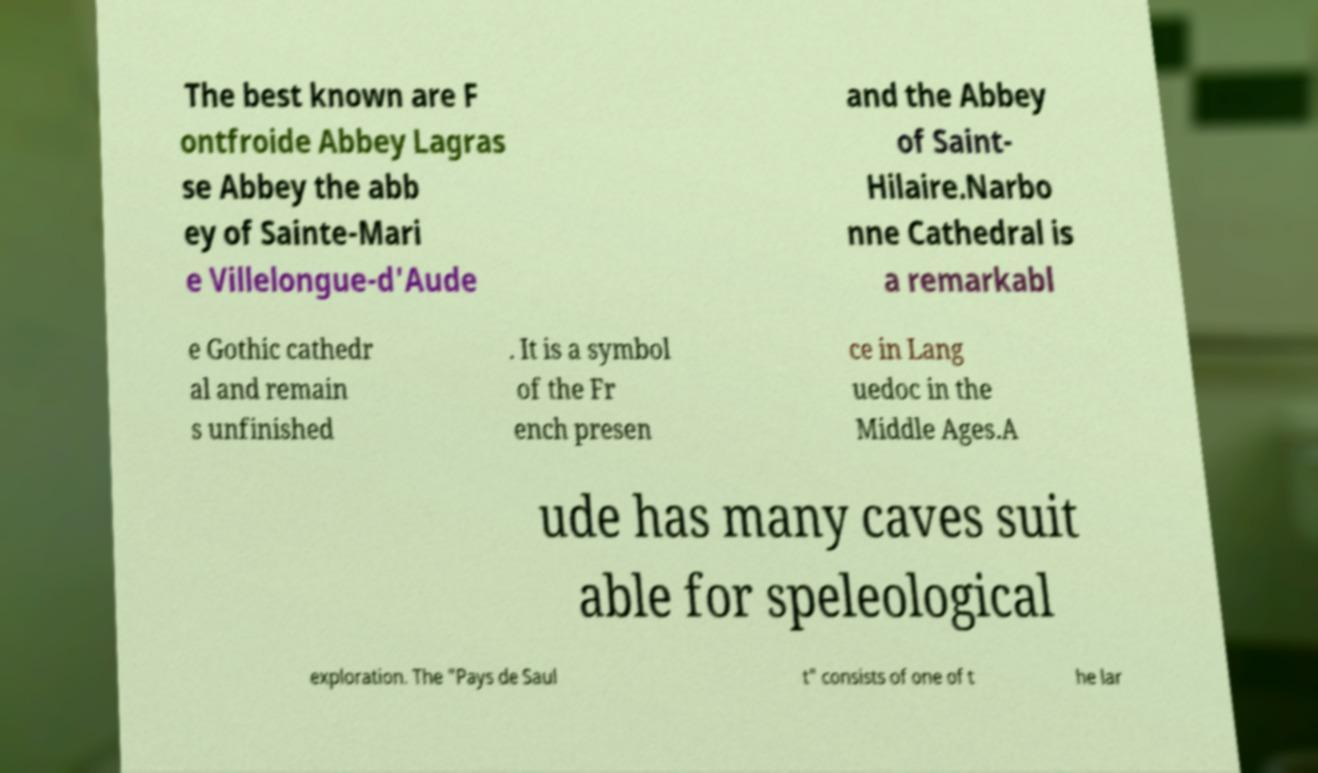For documentation purposes, I need the text within this image transcribed. Could you provide that? The best known are F ontfroide Abbey Lagras se Abbey the abb ey of Sainte-Mari e Villelongue-d'Aude and the Abbey of Saint- Hilaire.Narbo nne Cathedral is a remarkabl e Gothic cathedr al and remain s unfinished . It is a symbol of the Fr ench presen ce in Lang uedoc in the Middle Ages.A ude has many caves suit able for speleological exploration. The "Pays de Saul t" consists of one of t he lar 